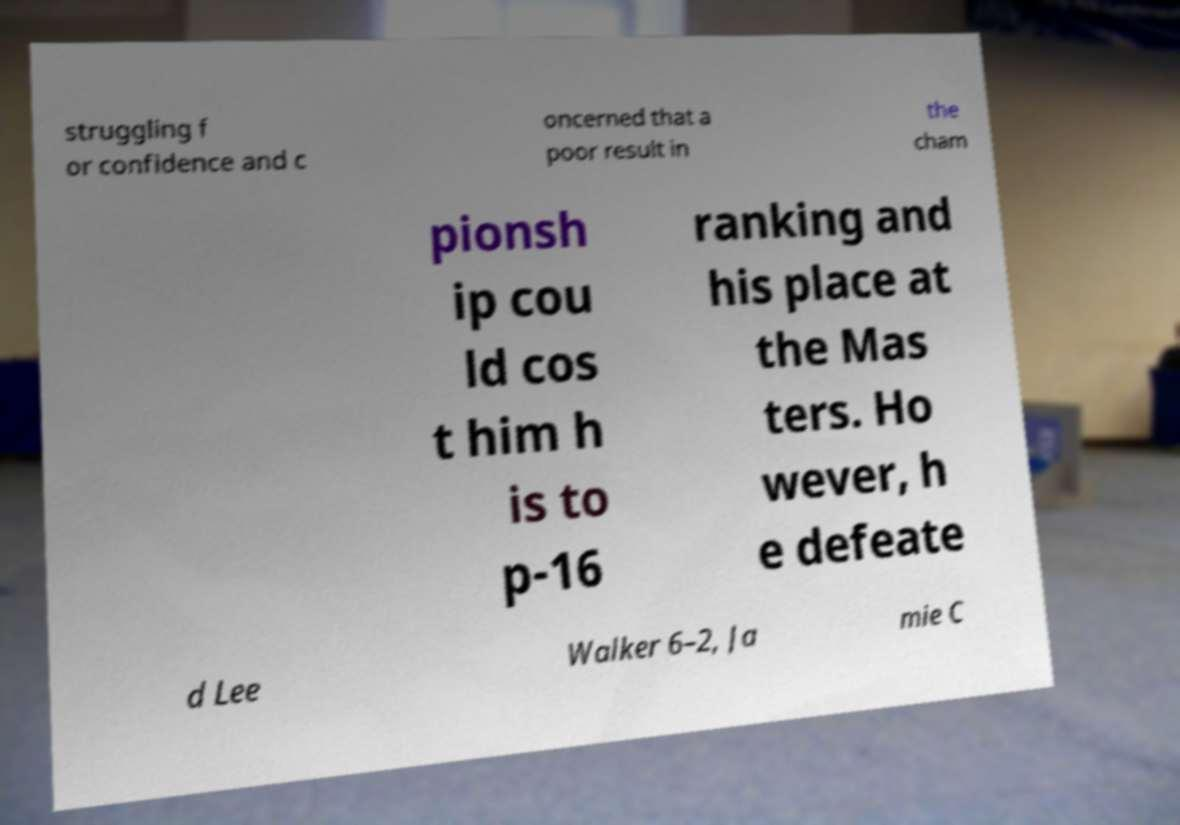For documentation purposes, I need the text within this image transcribed. Could you provide that? struggling f or confidence and c oncerned that a poor result in the cham pionsh ip cou ld cos t him h is to p-16 ranking and his place at the Mas ters. Ho wever, h e defeate d Lee Walker 6–2, Ja mie C 